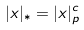Convert formula to latex. <formula><loc_0><loc_0><loc_500><loc_500>| x | _ { * } = | x | _ { p } ^ { c }</formula> 